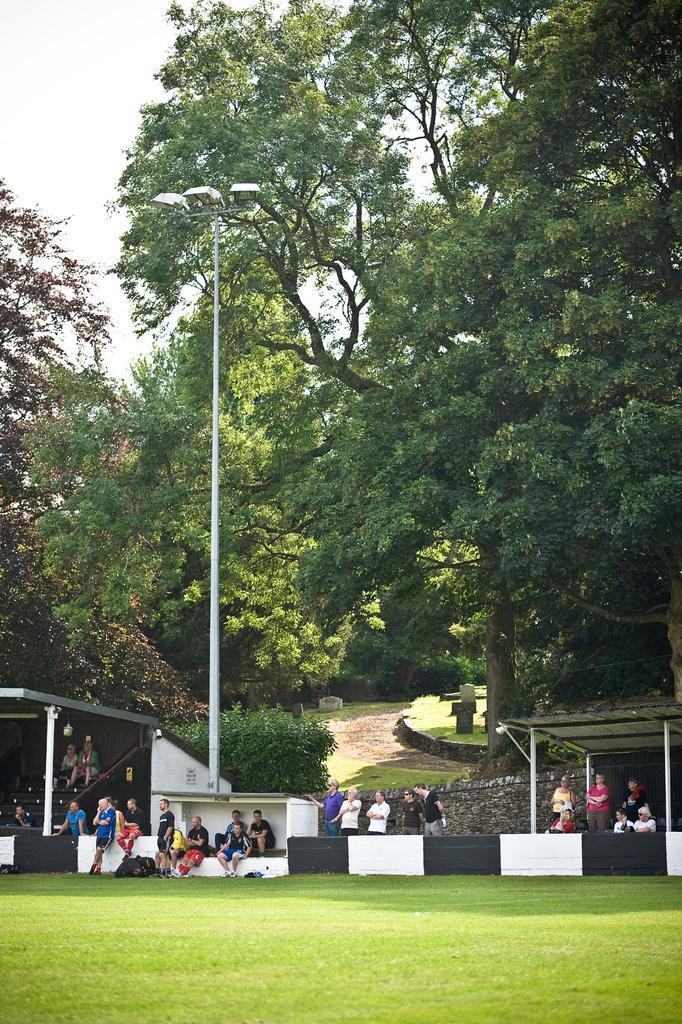How would you summarize this image in a sentence or two? In this picture we can see the ground, here we can see people, shelters, trees and an electric pole and we can see sky in the background. 